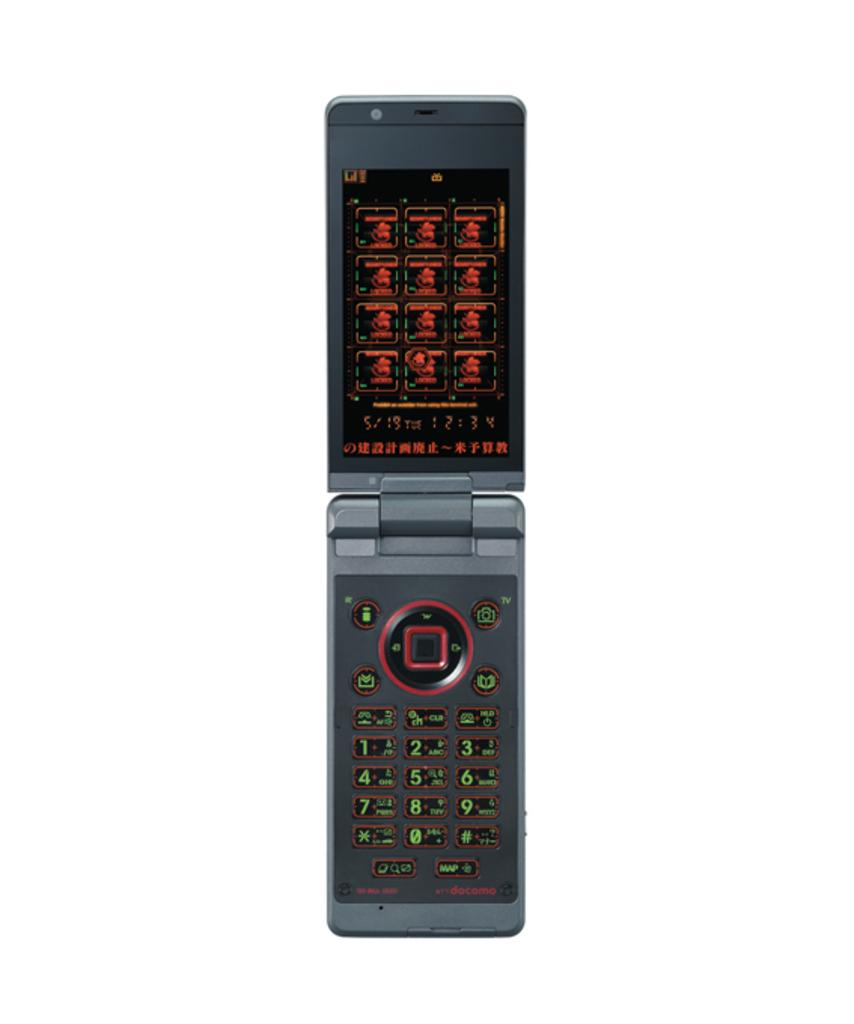<image>
Share a concise interpretation of the image provided. A grey old style flip phone by docomo 